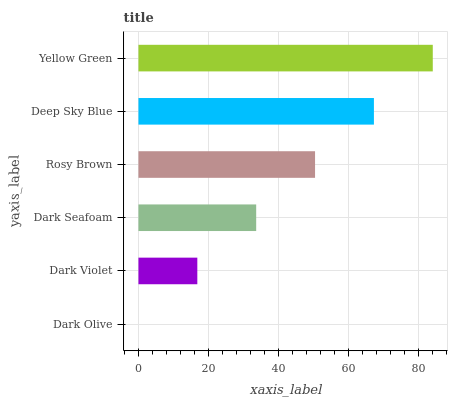Is Dark Olive the minimum?
Answer yes or no. Yes. Is Yellow Green the maximum?
Answer yes or no. Yes. Is Dark Violet the minimum?
Answer yes or no. No. Is Dark Violet the maximum?
Answer yes or no. No. Is Dark Violet greater than Dark Olive?
Answer yes or no. Yes. Is Dark Olive less than Dark Violet?
Answer yes or no. Yes. Is Dark Olive greater than Dark Violet?
Answer yes or no. No. Is Dark Violet less than Dark Olive?
Answer yes or no. No. Is Rosy Brown the high median?
Answer yes or no. Yes. Is Dark Seafoam the low median?
Answer yes or no. Yes. Is Yellow Green the high median?
Answer yes or no. No. Is Dark Olive the low median?
Answer yes or no. No. 